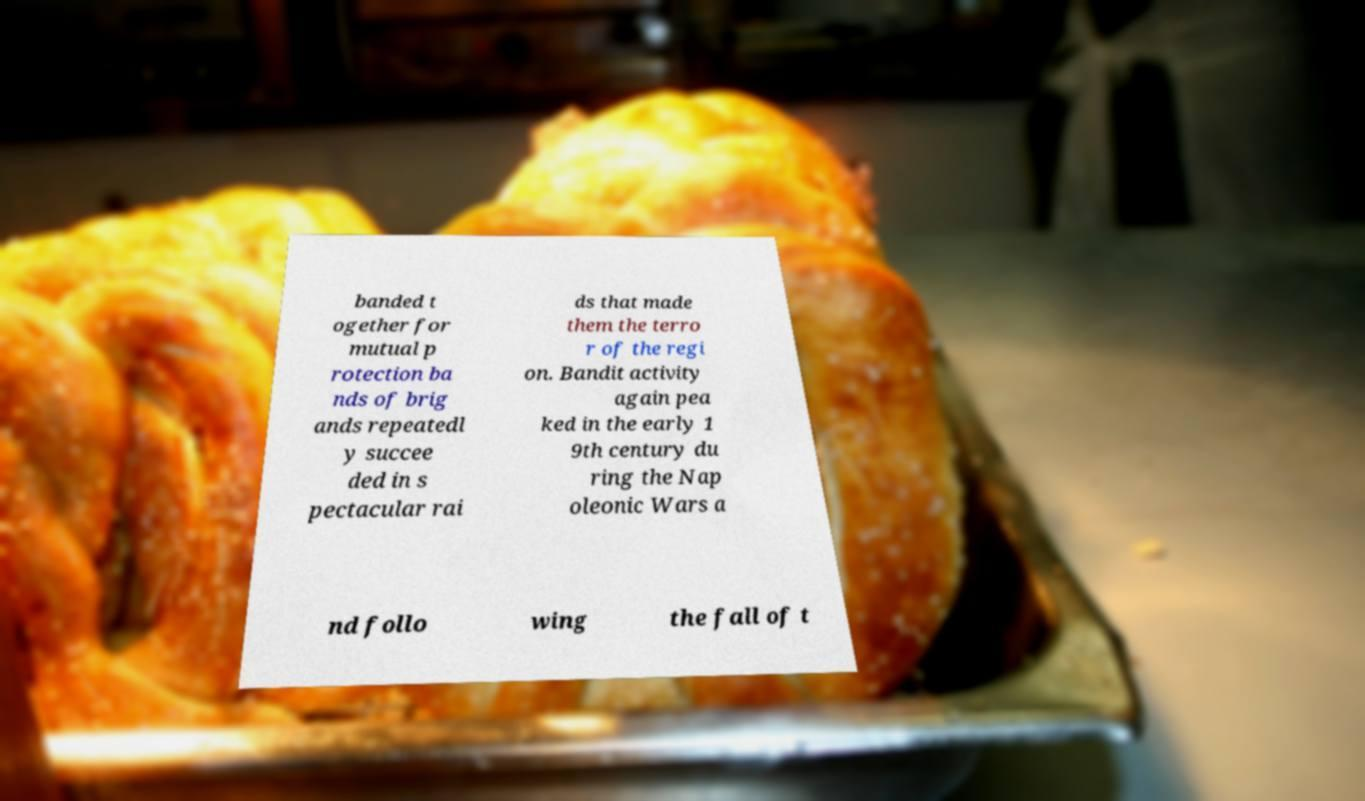Can you accurately transcribe the text from the provided image for me? banded t ogether for mutual p rotection ba nds of brig ands repeatedl y succee ded in s pectacular rai ds that made them the terro r of the regi on. Bandit activity again pea ked in the early 1 9th century du ring the Nap oleonic Wars a nd follo wing the fall of t 